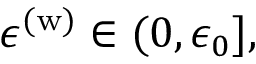<formula> <loc_0><loc_0><loc_500><loc_500>\epsilon ^ { ( w ) } \in ( 0 , \epsilon _ { 0 } ] ,</formula> 